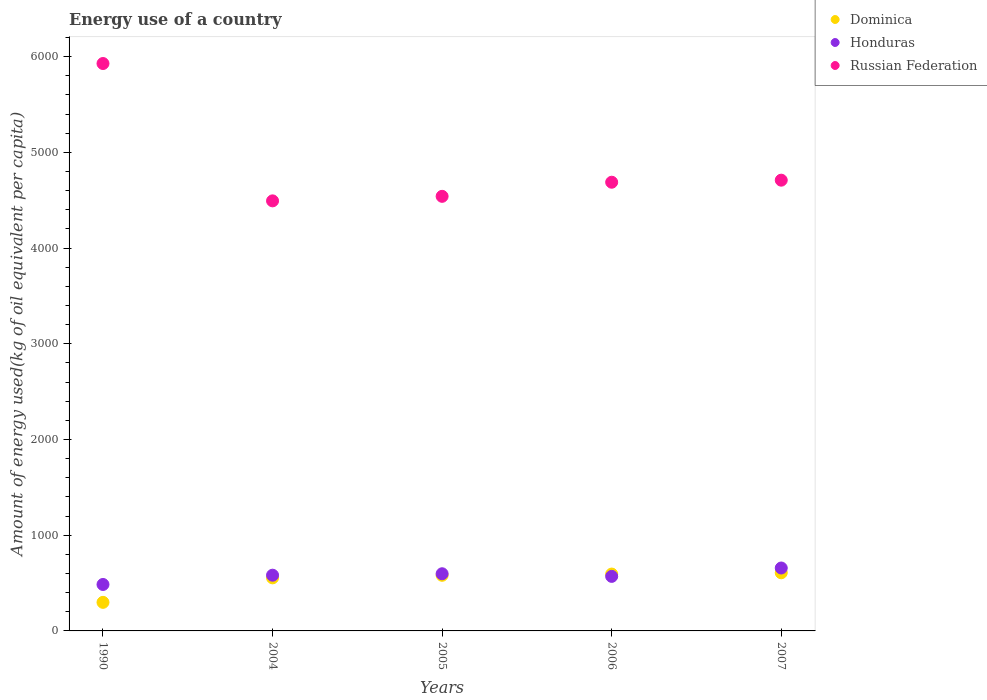What is the amount of energy used in in Russian Federation in 2007?
Offer a very short reply. 4709.85. Across all years, what is the maximum amount of energy used in in Dominica?
Give a very brief answer. 607.39. Across all years, what is the minimum amount of energy used in in Honduras?
Offer a terse response. 485.29. In which year was the amount of energy used in in Honduras maximum?
Keep it short and to the point. 2007. What is the total amount of energy used in in Honduras in the graph?
Provide a short and direct response. 2892.26. What is the difference between the amount of energy used in in Dominica in 1990 and that in 2006?
Your answer should be very brief. -295.65. What is the difference between the amount of energy used in in Honduras in 2006 and the amount of energy used in in Dominica in 2007?
Your answer should be very brief. -37.44. What is the average amount of energy used in in Russian Federation per year?
Offer a very short reply. 4872.34. In the year 1990, what is the difference between the amount of energy used in in Dominica and amount of energy used in in Honduras?
Your response must be concise. -186.8. In how many years, is the amount of energy used in in Honduras greater than 5000 kg?
Your answer should be compact. 0. What is the ratio of the amount of energy used in in Russian Federation in 2004 to that in 2005?
Your response must be concise. 0.99. Is the amount of energy used in in Honduras in 1990 less than that in 2007?
Make the answer very short. Yes. What is the difference between the highest and the second highest amount of energy used in in Russian Federation?
Your answer should be very brief. 1218.94. What is the difference between the highest and the lowest amount of energy used in in Honduras?
Make the answer very short. 172.1. In how many years, is the amount of energy used in in Russian Federation greater than the average amount of energy used in in Russian Federation taken over all years?
Provide a succinct answer. 1. Is the sum of the amount of energy used in in Russian Federation in 1990 and 2004 greater than the maximum amount of energy used in in Honduras across all years?
Your answer should be very brief. Yes. Is it the case that in every year, the sum of the amount of energy used in in Honduras and amount of energy used in in Russian Federation  is greater than the amount of energy used in in Dominica?
Make the answer very short. Yes. Is the amount of energy used in in Russian Federation strictly greater than the amount of energy used in in Honduras over the years?
Ensure brevity in your answer.  Yes. What is the difference between two consecutive major ticks on the Y-axis?
Give a very brief answer. 1000. Are the values on the major ticks of Y-axis written in scientific E-notation?
Provide a succinct answer. No. Does the graph contain any zero values?
Provide a short and direct response. No. Does the graph contain grids?
Offer a very short reply. No. Where does the legend appear in the graph?
Your answer should be very brief. Top right. How are the legend labels stacked?
Make the answer very short. Vertical. What is the title of the graph?
Ensure brevity in your answer.  Energy use of a country. Does "OECD members" appear as one of the legend labels in the graph?
Offer a terse response. No. What is the label or title of the X-axis?
Your answer should be very brief. Years. What is the label or title of the Y-axis?
Offer a terse response. Amount of energy used(kg of oil equivalent per capita). What is the Amount of energy used(kg of oil equivalent per capita) of Dominica in 1990?
Provide a succinct answer. 298.49. What is the Amount of energy used(kg of oil equivalent per capita) in Honduras in 1990?
Provide a short and direct response. 485.29. What is the Amount of energy used(kg of oil equivalent per capita) in Russian Federation in 1990?
Make the answer very short. 5928.79. What is the Amount of energy used(kg of oil equivalent per capita) in Dominica in 2004?
Provide a short and direct response. 554.57. What is the Amount of energy used(kg of oil equivalent per capita) in Honduras in 2004?
Make the answer very short. 582.26. What is the Amount of energy used(kg of oil equivalent per capita) in Russian Federation in 2004?
Keep it short and to the point. 4493.69. What is the Amount of energy used(kg of oil equivalent per capita) of Dominica in 2005?
Your answer should be very brief. 581.21. What is the Amount of energy used(kg of oil equivalent per capita) in Honduras in 2005?
Provide a short and direct response. 597.36. What is the Amount of energy used(kg of oil equivalent per capita) of Russian Federation in 2005?
Make the answer very short. 4540.96. What is the Amount of energy used(kg of oil equivalent per capita) of Dominica in 2006?
Provide a succinct answer. 594.14. What is the Amount of energy used(kg of oil equivalent per capita) of Honduras in 2006?
Make the answer very short. 569.94. What is the Amount of energy used(kg of oil equivalent per capita) of Russian Federation in 2006?
Provide a succinct answer. 4688.4. What is the Amount of energy used(kg of oil equivalent per capita) of Dominica in 2007?
Ensure brevity in your answer.  607.39. What is the Amount of energy used(kg of oil equivalent per capita) of Honduras in 2007?
Offer a terse response. 657.4. What is the Amount of energy used(kg of oil equivalent per capita) of Russian Federation in 2007?
Your answer should be compact. 4709.85. Across all years, what is the maximum Amount of energy used(kg of oil equivalent per capita) in Dominica?
Ensure brevity in your answer.  607.39. Across all years, what is the maximum Amount of energy used(kg of oil equivalent per capita) of Honduras?
Ensure brevity in your answer.  657.4. Across all years, what is the maximum Amount of energy used(kg of oil equivalent per capita) of Russian Federation?
Your response must be concise. 5928.79. Across all years, what is the minimum Amount of energy used(kg of oil equivalent per capita) of Dominica?
Provide a short and direct response. 298.49. Across all years, what is the minimum Amount of energy used(kg of oil equivalent per capita) of Honduras?
Give a very brief answer. 485.29. Across all years, what is the minimum Amount of energy used(kg of oil equivalent per capita) of Russian Federation?
Your answer should be compact. 4493.69. What is the total Amount of energy used(kg of oil equivalent per capita) in Dominica in the graph?
Offer a terse response. 2635.81. What is the total Amount of energy used(kg of oil equivalent per capita) of Honduras in the graph?
Your response must be concise. 2892.26. What is the total Amount of energy used(kg of oil equivalent per capita) of Russian Federation in the graph?
Your answer should be very brief. 2.44e+04. What is the difference between the Amount of energy used(kg of oil equivalent per capita) in Dominica in 1990 and that in 2004?
Your answer should be compact. -256.07. What is the difference between the Amount of energy used(kg of oil equivalent per capita) in Honduras in 1990 and that in 2004?
Provide a succinct answer. -96.96. What is the difference between the Amount of energy used(kg of oil equivalent per capita) of Russian Federation in 1990 and that in 2004?
Provide a short and direct response. 1435.11. What is the difference between the Amount of energy used(kg of oil equivalent per capita) in Dominica in 1990 and that in 2005?
Provide a short and direct response. -282.72. What is the difference between the Amount of energy used(kg of oil equivalent per capita) of Honduras in 1990 and that in 2005?
Your response must be concise. -112.07. What is the difference between the Amount of energy used(kg of oil equivalent per capita) of Russian Federation in 1990 and that in 2005?
Your answer should be very brief. 1387.83. What is the difference between the Amount of energy used(kg of oil equivalent per capita) of Dominica in 1990 and that in 2006?
Provide a short and direct response. -295.65. What is the difference between the Amount of energy used(kg of oil equivalent per capita) of Honduras in 1990 and that in 2006?
Your response must be concise. -84.65. What is the difference between the Amount of energy used(kg of oil equivalent per capita) of Russian Federation in 1990 and that in 2006?
Make the answer very short. 1240.4. What is the difference between the Amount of energy used(kg of oil equivalent per capita) in Dominica in 1990 and that in 2007?
Keep it short and to the point. -308.89. What is the difference between the Amount of energy used(kg of oil equivalent per capita) in Honduras in 1990 and that in 2007?
Your answer should be compact. -172.1. What is the difference between the Amount of energy used(kg of oil equivalent per capita) of Russian Federation in 1990 and that in 2007?
Offer a terse response. 1218.94. What is the difference between the Amount of energy used(kg of oil equivalent per capita) in Dominica in 2004 and that in 2005?
Your answer should be compact. -26.65. What is the difference between the Amount of energy used(kg of oil equivalent per capita) in Honduras in 2004 and that in 2005?
Offer a very short reply. -15.11. What is the difference between the Amount of energy used(kg of oil equivalent per capita) in Russian Federation in 2004 and that in 2005?
Provide a short and direct response. -47.27. What is the difference between the Amount of energy used(kg of oil equivalent per capita) in Dominica in 2004 and that in 2006?
Provide a succinct answer. -39.58. What is the difference between the Amount of energy used(kg of oil equivalent per capita) of Honduras in 2004 and that in 2006?
Provide a succinct answer. 12.31. What is the difference between the Amount of energy used(kg of oil equivalent per capita) of Russian Federation in 2004 and that in 2006?
Your answer should be compact. -194.71. What is the difference between the Amount of energy used(kg of oil equivalent per capita) of Dominica in 2004 and that in 2007?
Ensure brevity in your answer.  -52.82. What is the difference between the Amount of energy used(kg of oil equivalent per capita) of Honduras in 2004 and that in 2007?
Give a very brief answer. -75.14. What is the difference between the Amount of energy used(kg of oil equivalent per capita) in Russian Federation in 2004 and that in 2007?
Your response must be concise. -216.17. What is the difference between the Amount of energy used(kg of oil equivalent per capita) in Dominica in 2005 and that in 2006?
Keep it short and to the point. -12.93. What is the difference between the Amount of energy used(kg of oil equivalent per capita) of Honduras in 2005 and that in 2006?
Provide a succinct answer. 27.42. What is the difference between the Amount of energy used(kg of oil equivalent per capita) of Russian Federation in 2005 and that in 2006?
Make the answer very short. -147.44. What is the difference between the Amount of energy used(kg of oil equivalent per capita) of Dominica in 2005 and that in 2007?
Your response must be concise. -26.17. What is the difference between the Amount of energy used(kg of oil equivalent per capita) of Honduras in 2005 and that in 2007?
Provide a short and direct response. -60.03. What is the difference between the Amount of energy used(kg of oil equivalent per capita) in Russian Federation in 2005 and that in 2007?
Provide a succinct answer. -168.89. What is the difference between the Amount of energy used(kg of oil equivalent per capita) of Dominica in 2006 and that in 2007?
Keep it short and to the point. -13.24. What is the difference between the Amount of energy used(kg of oil equivalent per capita) of Honduras in 2006 and that in 2007?
Provide a short and direct response. -87.46. What is the difference between the Amount of energy used(kg of oil equivalent per capita) in Russian Federation in 2006 and that in 2007?
Offer a terse response. -21.46. What is the difference between the Amount of energy used(kg of oil equivalent per capita) of Dominica in 1990 and the Amount of energy used(kg of oil equivalent per capita) of Honduras in 2004?
Your response must be concise. -283.76. What is the difference between the Amount of energy used(kg of oil equivalent per capita) in Dominica in 1990 and the Amount of energy used(kg of oil equivalent per capita) in Russian Federation in 2004?
Ensure brevity in your answer.  -4195.19. What is the difference between the Amount of energy used(kg of oil equivalent per capita) in Honduras in 1990 and the Amount of energy used(kg of oil equivalent per capita) in Russian Federation in 2004?
Give a very brief answer. -4008.39. What is the difference between the Amount of energy used(kg of oil equivalent per capita) in Dominica in 1990 and the Amount of energy used(kg of oil equivalent per capita) in Honduras in 2005?
Provide a short and direct response. -298.87. What is the difference between the Amount of energy used(kg of oil equivalent per capita) of Dominica in 1990 and the Amount of energy used(kg of oil equivalent per capita) of Russian Federation in 2005?
Provide a short and direct response. -4242.46. What is the difference between the Amount of energy used(kg of oil equivalent per capita) of Honduras in 1990 and the Amount of energy used(kg of oil equivalent per capita) of Russian Federation in 2005?
Give a very brief answer. -4055.66. What is the difference between the Amount of energy used(kg of oil equivalent per capita) of Dominica in 1990 and the Amount of energy used(kg of oil equivalent per capita) of Honduras in 2006?
Your response must be concise. -271.45. What is the difference between the Amount of energy used(kg of oil equivalent per capita) in Dominica in 1990 and the Amount of energy used(kg of oil equivalent per capita) in Russian Federation in 2006?
Keep it short and to the point. -4389.9. What is the difference between the Amount of energy used(kg of oil equivalent per capita) in Honduras in 1990 and the Amount of energy used(kg of oil equivalent per capita) in Russian Federation in 2006?
Keep it short and to the point. -4203.1. What is the difference between the Amount of energy used(kg of oil equivalent per capita) in Dominica in 1990 and the Amount of energy used(kg of oil equivalent per capita) in Honduras in 2007?
Your answer should be compact. -358.9. What is the difference between the Amount of energy used(kg of oil equivalent per capita) of Dominica in 1990 and the Amount of energy used(kg of oil equivalent per capita) of Russian Federation in 2007?
Give a very brief answer. -4411.36. What is the difference between the Amount of energy used(kg of oil equivalent per capita) in Honduras in 1990 and the Amount of energy used(kg of oil equivalent per capita) in Russian Federation in 2007?
Give a very brief answer. -4224.56. What is the difference between the Amount of energy used(kg of oil equivalent per capita) in Dominica in 2004 and the Amount of energy used(kg of oil equivalent per capita) in Honduras in 2005?
Give a very brief answer. -42.8. What is the difference between the Amount of energy used(kg of oil equivalent per capita) of Dominica in 2004 and the Amount of energy used(kg of oil equivalent per capita) of Russian Federation in 2005?
Keep it short and to the point. -3986.39. What is the difference between the Amount of energy used(kg of oil equivalent per capita) in Honduras in 2004 and the Amount of energy used(kg of oil equivalent per capita) in Russian Federation in 2005?
Provide a succinct answer. -3958.7. What is the difference between the Amount of energy used(kg of oil equivalent per capita) in Dominica in 2004 and the Amount of energy used(kg of oil equivalent per capita) in Honduras in 2006?
Offer a very short reply. -15.38. What is the difference between the Amount of energy used(kg of oil equivalent per capita) of Dominica in 2004 and the Amount of energy used(kg of oil equivalent per capita) of Russian Federation in 2006?
Provide a succinct answer. -4133.83. What is the difference between the Amount of energy used(kg of oil equivalent per capita) of Honduras in 2004 and the Amount of energy used(kg of oil equivalent per capita) of Russian Federation in 2006?
Give a very brief answer. -4106.14. What is the difference between the Amount of energy used(kg of oil equivalent per capita) of Dominica in 2004 and the Amount of energy used(kg of oil equivalent per capita) of Honduras in 2007?
Ensure brevity in your answer.  -102.83. What is the difference between the Amount of energy used(kg of oil equivalent per capita) of Dominica in 2004 and the Amount of energy used(kg of oil equivalent per capita) of Russian Federation in 2007?
Provide a succinct answer. -4155.28. What is the difference between the Amount of energy used(kg of oil equivalent per capita) of Honduras in 2004 and the Amount of energy used(kg of oil equivalent per capita) of Russian Federation in 2007?
Provide a short and direct response. -4127.59. What is the difference between the Amount of energy used(kg of oil equivalent per capita) in Dominica in 2005 and the Amount of energy used(kg of oil equivalent per capita) in Honduras in 2006?
Offer a terse response. 11.27. What is the difference between the Amount of energy used(kg of oil equivalent per capita) of Dominica in 2005 and the Amount of energy used(kg of oil equivalent per capita) of Russian Federation in 2006?
Provide a succinct answer. -4107.18. What is the difference between the Amount of energy used(kg of oil equivalent per capita) of Honduras in 2005 and the Amount of energy used(kg of oil equivalent per capita) of Russian Federation in 2006?
Ensure brevity in your answer.  -4091.03. What is the difference between the Amount of energy used(kg of oil equivalent per capita) of Dominica in 2005 and the Amount of energy used(kg of oil equivalent per capita) of Honduras in 2007?
Keep it short and to the point. -76.18. What is the difference between the Amount of energy used(kg of oil equivalent per capita) of Dominica in 2005 and the Amount of energy used(kg of oil equivalent per capita) of Russian Federation in 2007?
Keep it short and to the point. -4128.64. What is the difference between the Amount of energy used(kg of oil equivalent per capita) in Honduras in 2005 and the Amount of energy used(kg of oil equivalent per capita) in Russian Federation in 2007?
Offer a terse response. -4112.49. What is the difference between the Amount of energy used(kg of oil equivalent per capita) in Dominica in 2006 and the Amount of energy used(kg of oil equivalent per capita) in Honduras in 2007?
Your response must be concise. -63.26. What is the difference between the Amount of energy used(kg of oil equivalent per capita) of Dominica in 2006 and the Amount of energy used(kg of oil equivalent per capita) of Russian Federation in 2007?
Offer a very short reply. -4115.71. What is the difference between the Amount of energy used(kg of oil equivalent per capita) of Honduras in 2006 and the Amount of energy used(kg of oil equivalent per capita) of Russian Federation in 2007?
Your answer should be compact. -4139.91. What is the average Amount of energy used(kg of oil equivalent per capita) in Dominica per year?
Your answer should be very brief. 527.16. What is the average Amount of energy used(kg of oil equivalent per capita) in Honduras per year?
Your answer should be very brief. 578.45. What is the average Amount of energy used(kg of oil equivalent per capita) in Russian Federation per year?
Your answer should be very brief. 4872.34. In the year 1990, what is the difference between the Amount of energy used(kg of oil equivalent per capita) of Dominica and Amount of energy used(kg of oil equivalent per capita) of Honduras?
Give a very brief answer. -186.8. In the year 1990, what is the difference between the Amount of energy used(kg of oil equivalent per capita) in Dominica and Amount of energy used(kg of oil equivalent per capita) in Russian Federation?
Keep it short and to the point. -5630.3. In the year 1990, what is the difference between the Amount of energy used(kg of oil equivalent per capita) of Honduras and Amount of energy used(kg of oil equivalent per capita) of Russian Federation?
Your answer should be very brief. -5443.5. In the year 2004, what is the difference between the Amount of energy used(kg of oil equivalent per capita) in Dominica and Amount of energy used(kg of oil equivalent per capita) in Honduras?
Make the answer very short. -27.69. In the year 2004, what is the difference between the Amount of energy used(kg of oil equivalent per capita) of Dominica and Amount of energy used(kg of oil equivalent per capita) of Russian Federation?
Provide a succinct answer. -3939.12. In the year 2004, what is the difference between the Amount of energy used(kg of oil equivalent per capita) in Honduras and Amount of energy used(kg of oil equivalent per capita) in Russian Federation?
Ensure brevity in your answer.  -3911.43. In the year 2005, what is the difference between the Amount of energy used(kg of oil equivalent per capita) in Dominica and Amount of energy used(kg of oil equivalent per capita) in Honduras?
Provide a short and direct response. -16.15. In the year 2005, what is the difference between the Amount of energy used(kg of oil equivalent per capita) of Dominica and Amount of energy used(kg of oil equivalent per capita) of Russian Federation?
Ensure brevity in your answer.  -3959.74. In the year 2005, what is the difference between the Amount of energy used(kg of oil equivalent per capita) in Honduras and Amount of energy used(kg of oil equivalent per capita) in Russian Federation?
Offer a terse response. -3943.59. In the year 2006, what is the difference between the Amount of energy used(kg of oil equivalent per capita) in Dominica and Amount of energy used(kg of oil equivalent per capita) in Honduras?
Provide a succinct answer. 24.2. In the year 2006, what is the difference between the Amount of energy used(kg of oil equivalent per capita) of Dominica and Amount of energy used(kg of oil equivalent per capita) of Russian Federation?
Provide a succinct answer. -4094.25. In the year 2006, what is the difference between the Amount of energy used(kg of oil equivalent per capita) of Honduras and Amount of energy used(kg of oil equivalent per capita) of Russian Federation?
Your answer should be very brief. -4118.45. In the year 2007, what is the difference between the Amount of energy used(kg of oil equivalent per capita) in Dominica and Amount of energy used(kg of oil equivalent per capita) in Honduras?
Give a very brief answer. -50.01. In the year 2007, what is the difference between the Amount of energy used(kg of oil equivalent per capita) of Dominica and Amount of energy used(kg of oil equivalent per capita) of Russian Federation?
Offer a very short reply. -4102.46. In the year 2007, what is the difference between the Amount of energy used(kg of oil equivalent per capita) in Honduras and Amount of energy used(kg of oil equivalent per capita) in Russian Federation?
Your answer should be compact. -4052.45. What is the ratio of the Amount of energy used(kg of oil equivalent per capita) in Dominica in 1990 to that in 2004?
Make the answer very short. 0.54. What is the ratio of the Amount of energy used(kg of oil equivalent per capita) in Honduras in 1990 to that in 2004?
Make the answer very short. 0.83. What is the ratio of the Amount of energy used(kg of oil equivalent per capita) of Russian Federation in 1990 to that in 2004?
Offer a very short reply. 1.32. What is the ratio of the Amount of energy used(kg of oil equivalent per capita) in Dominica in 1990 to that in 2005?
Provide a succinct answer. 0.51. What is the ratio of the Amount of energy used(kg of oil equivalent per capita) in Honduras in 1990 to that in 2005?
Your answer should be very brief. 0.81. What is the ratio of the Amount of energy used(kg of oil equivalent per capita) in Russian Federation in 1990 to that in 2005?
Your answer should be very brief. 1.31. What is the ratio of the Amount of energy used(kg of oil equivalent per capita) in Dominica in 1990 to that in 2006?
Keep it short and to the point. 0.5. What is the ratio of the Amount of energy used(kg of oil equivalent per capita) in Honduras in 1990 to that in 2006?
Your answer should be very brief. 0.85. What is the ratio of the Amount of energy used(kg of oil equivalent per capita) in Russian Federation in 1990 to that in 2006?
Ensure brevity in your answer.  1.26. What is the ratio of the Amount of energy used(kg of oil equivalent per capita) of Dominica in 1990 to that in 2007?
Ensure brevity in your answer.  0.49. What is the ratio of the Amount of energy used(kg of oil equivalent per capita) of Honduras in 1990 to that in 2007?
Your response must be concise. 0.74. What is the ratio of the Amount of energy used(kg of oil equivalent per capita) of Russian Federation in 1990 to that in 2007?
Your response must be concise. 1.26. What is the ratio of the Amount of energy used(kg of oil equivalent per capita) in Dominica in 2004 to that in 2005?
Give a very brief answer. 0.95. What is the ratio of the Amount of energy used(kg of oil equivalent per capita) in Honduras in 2004 to that in 2005?
Your answer should be compact. 0.97. What is the ratio of the Amount of energy used(kg of oil equivalent per capita) in Russian Federation in 2004 to that in 2005?
Your answer should be compact. 0.99. What is the ratio of the Amount of energy used(kg of oil equivalent per capita) in Dominica in 2004 to that in 2006?
Your answer should be very brief. 0.93. What is the ratio of the Amount of energy used(kg of oil equivalent per capita) of Honduras in 2004 to that in 2006?
Your response must be concise. 1.02. What is the ratio of the Amount of energy used(kg of oil equivalent per capita) of Russian Federation in 2004 to that in 2006?
Offer a terse response. 0.96. What is the ratio of the Amount of energy used(kg of oil equivalent per capita) of Honduras in 2004 to that in 2007?
Make the answer very short. 0.89. What is the ratio of the Amount of energy used(kg of oil equivalent per capita) in Russian Federation in 2004 to that in 2007?
Your answer should be compact. 0.95. What is the ratio of the Amount of energy used(kg of oil equivalent per capita) of Dominica in 2005 to that in 2006?
Keep it short and to the point. 0.98. What is the ratio of the Amount of energy used(kg of oil equivalent per capita) in Honduras in 2005 to that in 2006?
Make the answer very short. 1.05. What is the ratio of the Amount of energy used(kg of oil equivalent per capita) of Russian Federation in 2005 to that in 2006?
Make the answer very short. 0.97. What is the ratio of the Amount of energy used(kg of oil equivalent per capita) of Dominica in 2005 to that in 2007?
Provide a succinct answer. 0.96. What is the ratio of the Amount of energy used(kg of oil equivalent per capita) in Honduras in 2005 to that in 2007?
Make the answer very short. 0.91. What is the ratio of the Amount of energy used(kg of oil equivalent per capita) of Russian Federation in 2005 to that in 2007?
Offer a very short reply. 0.96. What is the ratio of the Amount of energy used(kg of oil equivalent per capita) in Dominica in 2006 to that in 2007?
Offer a very short reply. 0.98. What is the ratio of the Amount of energy used(kg of oil equivalent per capita) of Honduras in 2006 to that in 2007?
Your response must be concise. 0.87. What is the ratio of the Amount of energy used(kg of oil equivalent per capita) in Russian Federation in 2006 to that in 2007?
Keep it short and to the point. 1. What is the difference between the highest and the second highest Amount of energy used(kg of oil equivalent per capita) of Dominica?
Your answer should be compact. 13.24. What is the difference between the highest and the second highest Amount of energy used(kg of oil equivalent per capita) of Honduras?
Offer a very short reply. 60.03. What is the difference between the highest and the second highest Amount of energy used(kg of oil equivalent per capita) of Russian Federation?
Your answer should be compact. 1218.94. What is the difference between the highest and the lowest Amount of energy used(kg of oil equivalent per capita) in Dominica?
Ensure brevity in your answer.  308.89. What is the difference between the highest and the lowest Amount of energy used(kg of oil equivalent per capita) of Honduras?
Your response must be concise. 172.1. What is the difference between the highest and the lowest Amount of energy used(kg of oil equivalent per capita) of Russian Federation?
Offer a very short reply. 1435.11. 